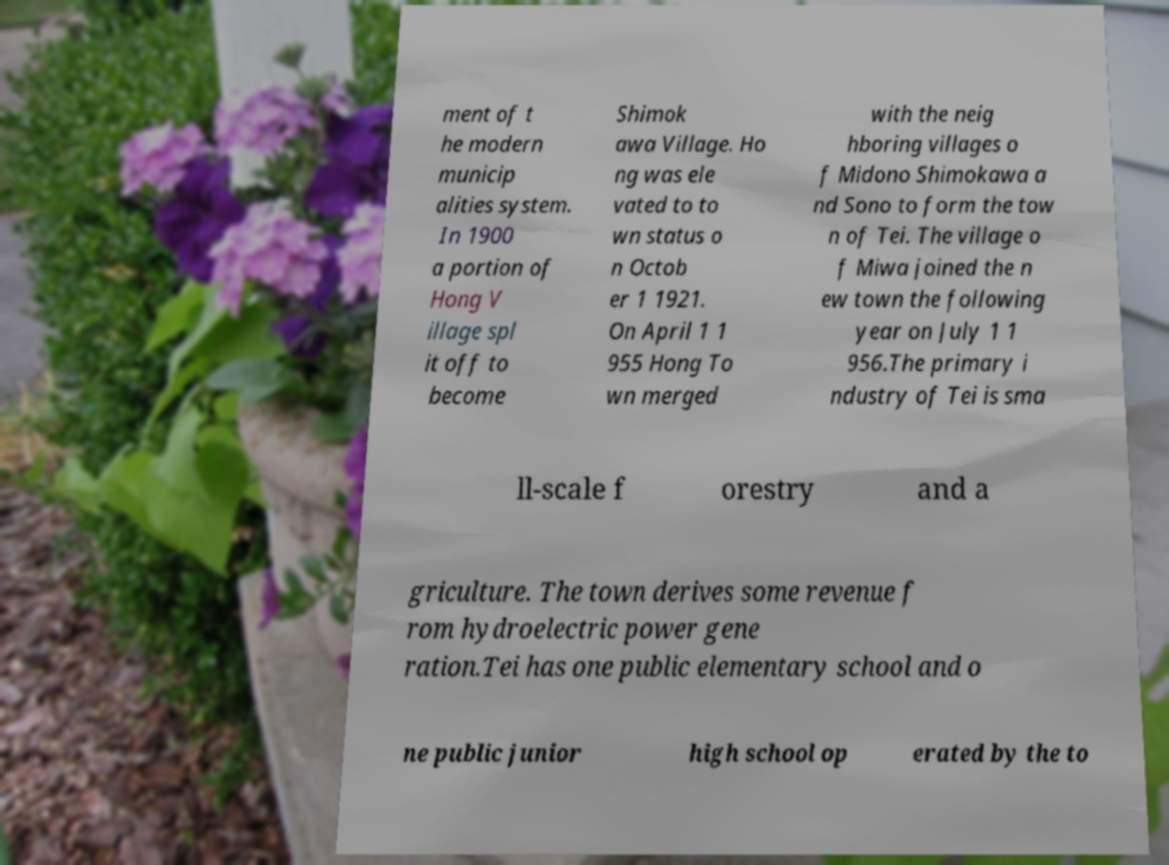Can you accurately transcribe the text from the provided image for me? ment of t he modern municip alities system. In 1900 a portion of Hong V illage spl it off to become Shimok awa Village. Ho ng was ele vated to to wn status o n Octob er 1 1921. On April 1 1 955 Hong To wn merged with the neig hboring villages o f Midono Shimokawa a nd Sono to form the tow n of Tei. The village o f Miwa joined the n ew town the following year on July 1 1 956.The primary i ndustry of Tei is sma ll-scale f orestry and a griculture. The town derives some revenue f rom hydroelectric power gene ration.Tei has one public elementary school and o ne public junior high school op erated by the to 